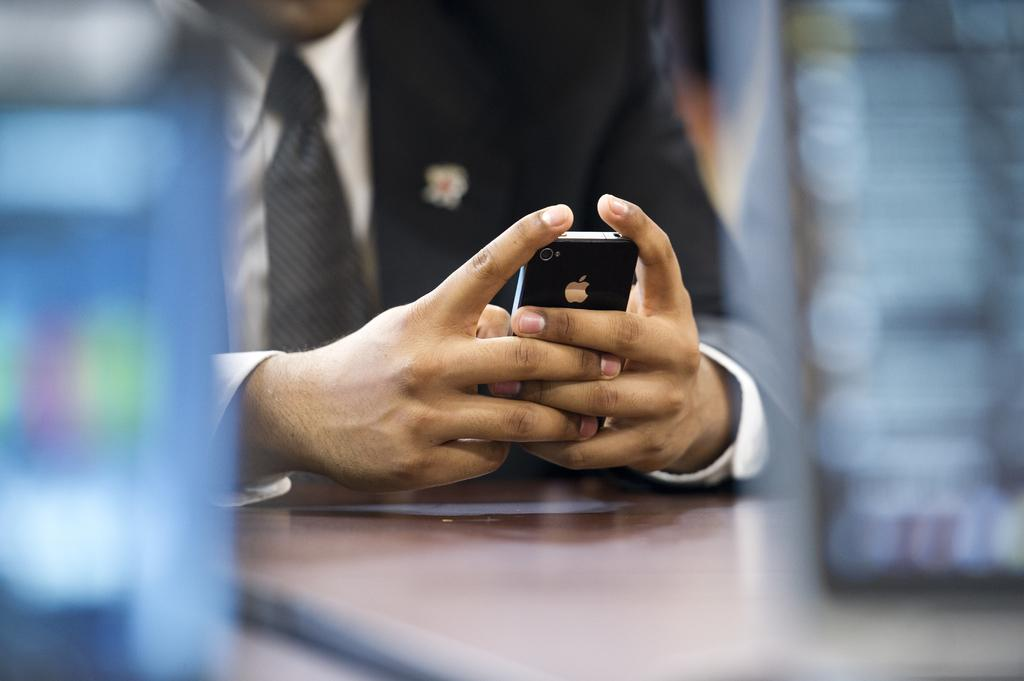What is the person in the image doing? The person is sitting in the image. What is the person holding in the image? The person is holding a phone in the image. What is the person wearing in the image? The person is wearing a black suit, a white shirt, and a tie in the image. What is in front of the person in the image? There is a table in front of the person in the image. What type of iron can be seen on the person's skin in the image? There is no iron visible on the person's skin in the image. What type of camera is the person using to take a selfie in the image? There is no camera visible in the image, and the person is not taking a selfie. 